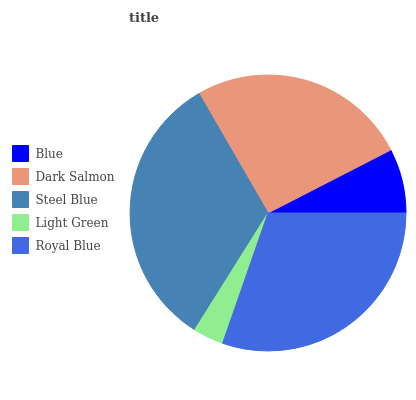Is Light Green the minimum?
Answer yes or no. Yes. Is Steel Blue the maximum?
Answer yes or no. Yes. Is Dark Salmon the minimum?
Answer yes or no. No. Is Dark Salmon the maximum?
Answer yes or no. No. Is Dark Salmon greater than Blue?
Answer yes or no. Yes. Is Blue less than Dark Salmon?
Answer yes or no. Yes. Is Blue greater than Dark Salmon?
Answer yes or no. No. Is Dark Salmon less than Blue?
Answer yes or no. No. Is Dark Salmon the high median?
Answer yes or no. Yes. Is Dark Salmon the low median?
Answer yes or no. Yes. Is Steel Blue the high median?
Answer yes or no. No. Is Light Green the low median?
Answer yes or no. No. 